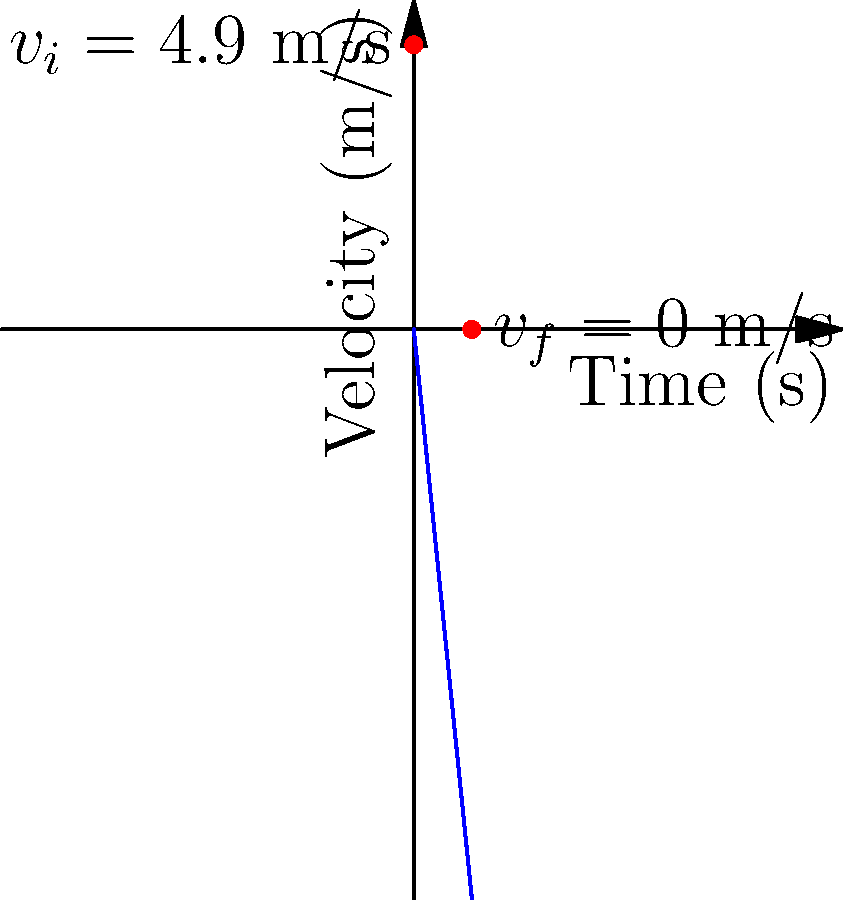A dancer is practicing a new routine that involves jumping. The velocity-time graph above shows the landing phase of a jump. If the dancer's mass is 55 kg, calculate the average impact force on their knee during the landing. Assume the initial velocity at the start of landing is 4.9 m/s, and the landing takes 1 second to complete. To solve this problem, we'll use the impulse-momentum theorem and Newton's Second Law. Let's break it down step-by-step:

1) First, we need to calculate the change in momentum:
   $\Delta p = m(v_f - v_i)$
   Where $m$ is mass, $v_f$ is final velocity, and $v_i$ is initial velocity.

2) From the graph, we can see:
   $v_i = 4.9$ m/s
   $v_f = 0$ m/s (the dancer comes to a stop)
   $m = 55$ kg

3) Calculating change in momentum:
   $\Delta p = 55(0 - 4.9) = -269.5$ kg⋅m/s

4) The impulse-momentum theorem states that impulse equals change in momentum:
   $F_{avg} \cdot \Delta t = \Delta p$

5) We know $\Delta t = 1$ s from the graph, so:
   $F_{avg} \cdot 1 = -269.5$
   $F_{avg} = -269.5$ N

6) The negative sign indicates the force is in the opposite direction of the initial velocity (upwards). The magnitude of the average force is 269.5 N.

7) However, this is just the additional force due to the impact. We need to add the force of gravity:
   $F_g = mg = 55 \cdot 9.8 = 539$ N

8) The total average force on the knee is:
   $F_{total} = 269.5 + 539 = 808.5$ N

Therefore, the average impact force on the dancer's knee during landing is approximately 808.5 N.
Answer: 808.5 N 